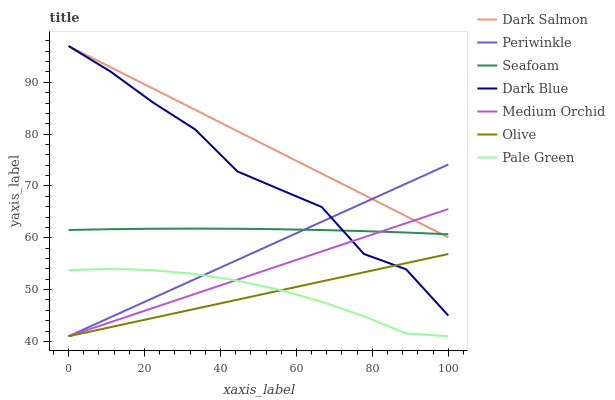Does Olive have the minimum area under the curve?
Answer yes or no. Yes. Does Dark Salmon have the maximum area under the curve?
Answer yes or no. Yes. Does Seafoam have the minimum area under the curve?
Answer yes or no. No. Does Seafoam have the maximum area under the curve?
Answer yes or no. No. Is Medium Orchid the smoothest?
Answer yes or no. Yes. Is Dark Blue the roughest?
Answer yes or no. Yes. Is Dark Salmon the smoothest?
Answer yes or no. No. Is Dark Salmon the roughest?
Answer yes or no. No. Does Medium Orchid have the lowest value?
Answer yes or no. Yes. Does Dark Salmon have the lowest value?
Answer yes or no. No. Does Dark Blue have the highest value?
Answer yes or no. Yes. Does Seafoam have the highest value?
Answer yes or no. No. Is Olive less than Seafoam?
Answer yes or no. Yes. Is Dark Salmon greater than Olive?
Answer yes or no. Yes. Does Dark Blue intersect Olive?
Answer yes or no. Yes. Is Dark Blue less than Olive?
Answer yes or no. No. Is Dark Blue greater than Olive?
Answer yes or no. No. Does Olive intersect Seafoam?
Answer yes or no. No. 